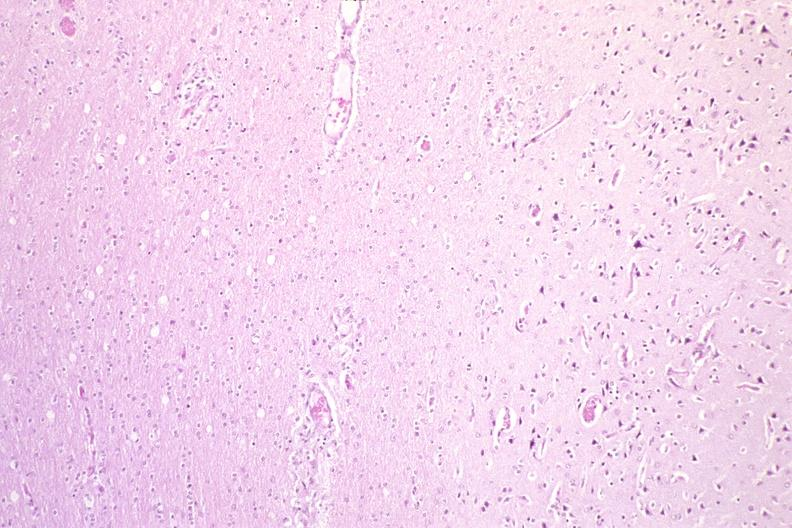where is this?
Answer the question using a single word or phrase. Nervous 